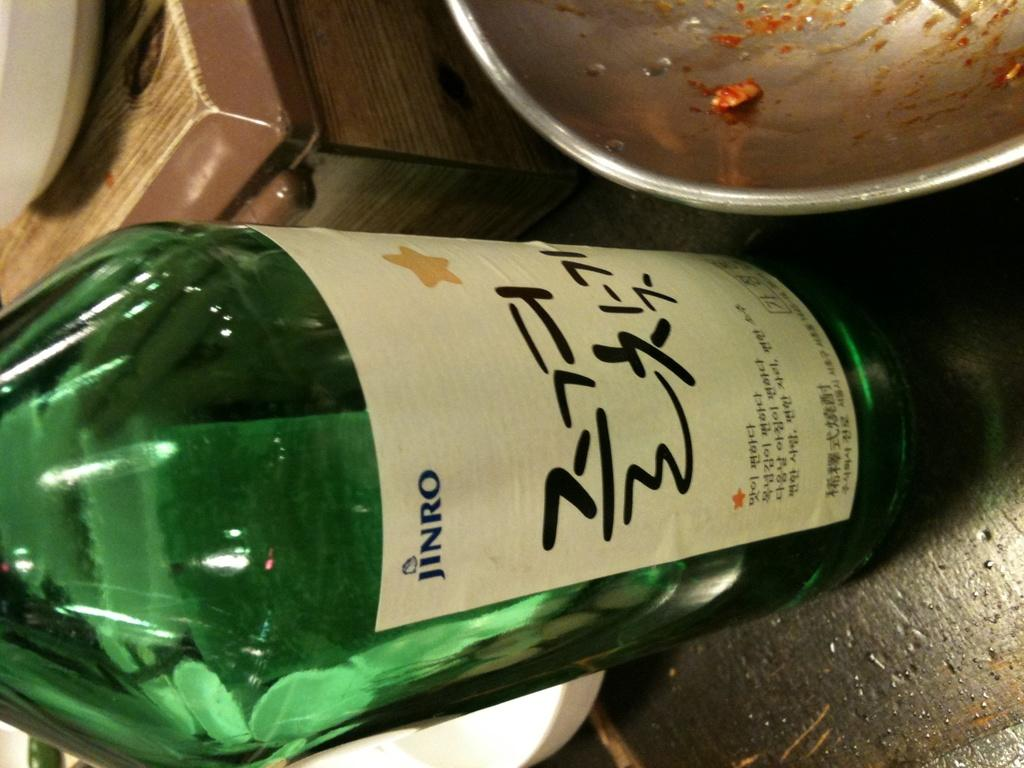<image>
Write a terse but informative summary of the picture. A green bottle of Jinro is next to a cooking pan. 